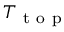Convert formula to latex. <formula><loc_0><loc_0><loc_500><loc_500>T _ { t o p }</formula> 